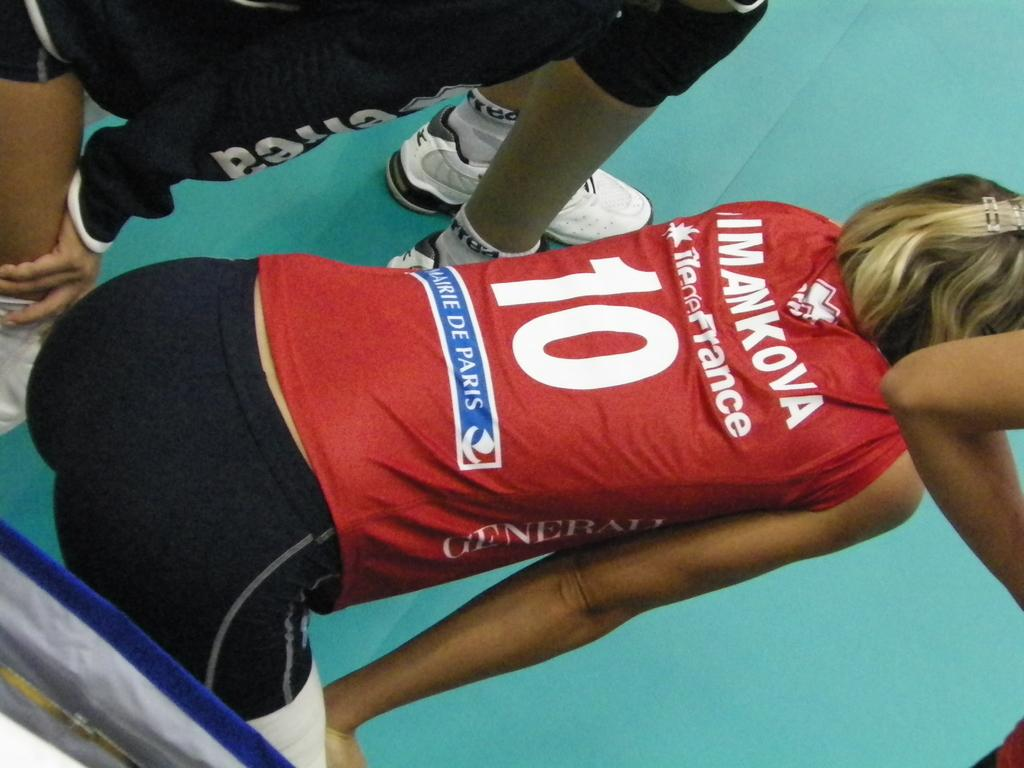<image>
Present a compact description of the photo's key features. a lady with the number 10 on the back of her shirt 